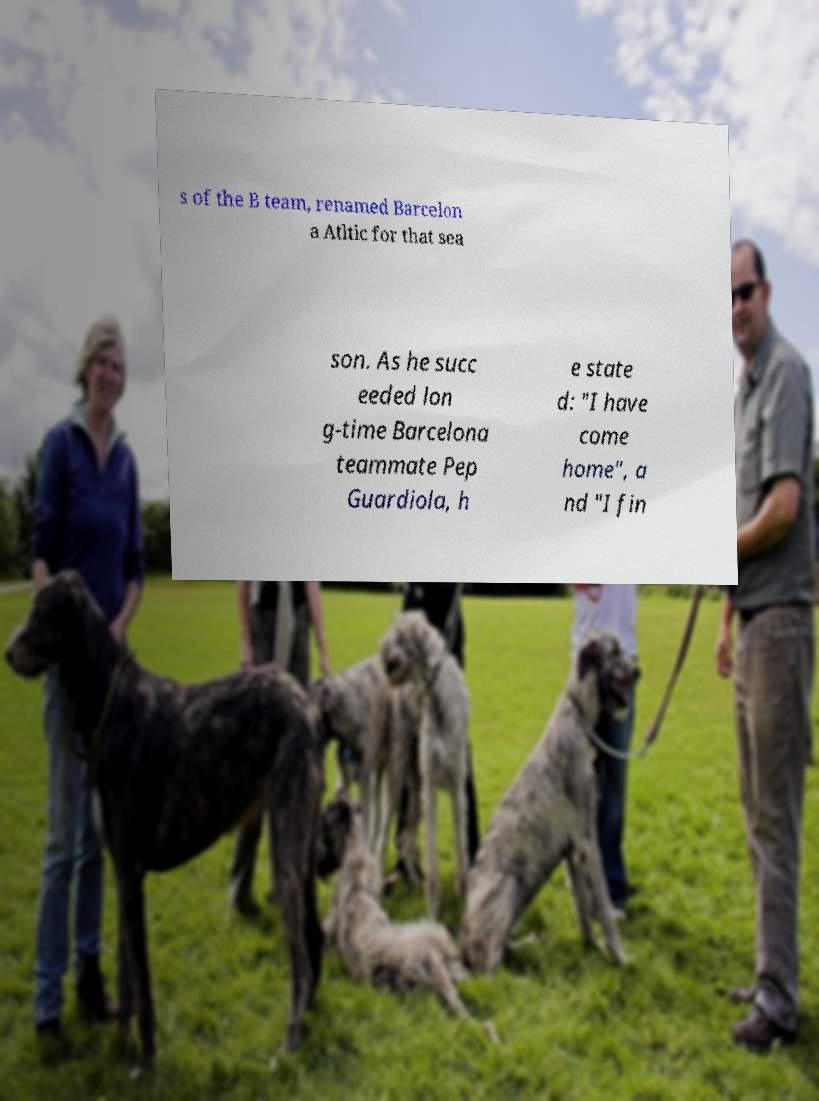What messages or text are displayed in this image? I need them in a readable, typed format. s of the B team, renamed Barcelon a Atltic for that sea son. As he succ eeded lon g-time Barcelona teammate Pep Guardiola, h e state d: "I have come home", a nd "I fin 